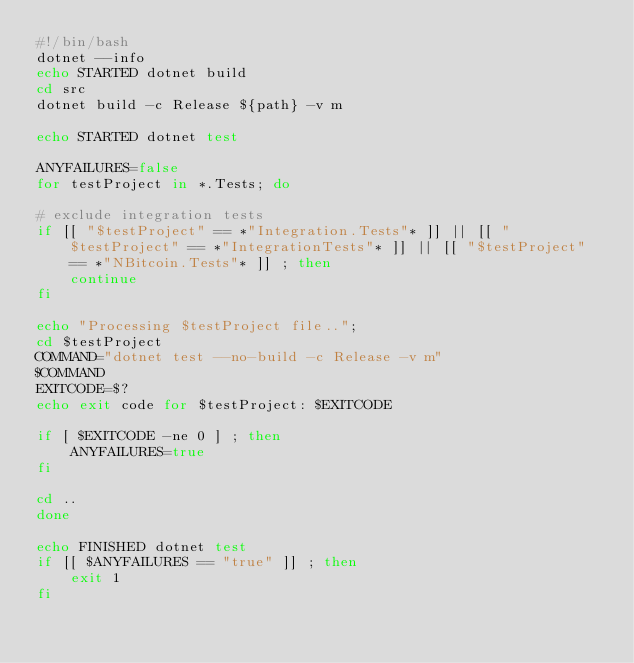Convert code to text. <code><loc_0><loc_0><loc_500><loc_500><_Bash_>#!/bin/bash
dotnet --info
echo STARTED dotnet build
cd src
dotnet build -c Release ${path} -v m

echo STARTED dotnet test

ANYFAILURES=false
for testProject in *.Tests; do

# exclude integration tests
if [[ "$testProject" == *"Integration.Tests"* ]] || [[ "$testProject" == *"IntegrationTests"* ]] || [[ "$testProject" == *"NBitcoin.Tests"* ]] ; then
    continue
fi

echo "Processing $testProject file.."; 
cd $testProject
COMMAND="dotnet test --no-build -c Release -v m"
$COMMAND
EXITCODE=$?
echo exit code for $testProject: $EXITCODE

if [ $EXITCODE -ne 0 ] ; then
    ANYFAILURES=true
fi

cd ..
done

echo FINISHED dotnet test
if [[ $ANYFAILURES == "true" ]] ; then
    exit 1
fi
</code> 